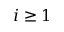<formula> <loc_0><loc_0><loc_500><loc_500>i \geq 1</formula> 